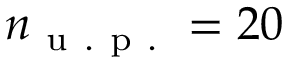<formula> <loc_0><loc_0><loc_500><loc_500>n _ { u . p . } = 2 0</formula> 